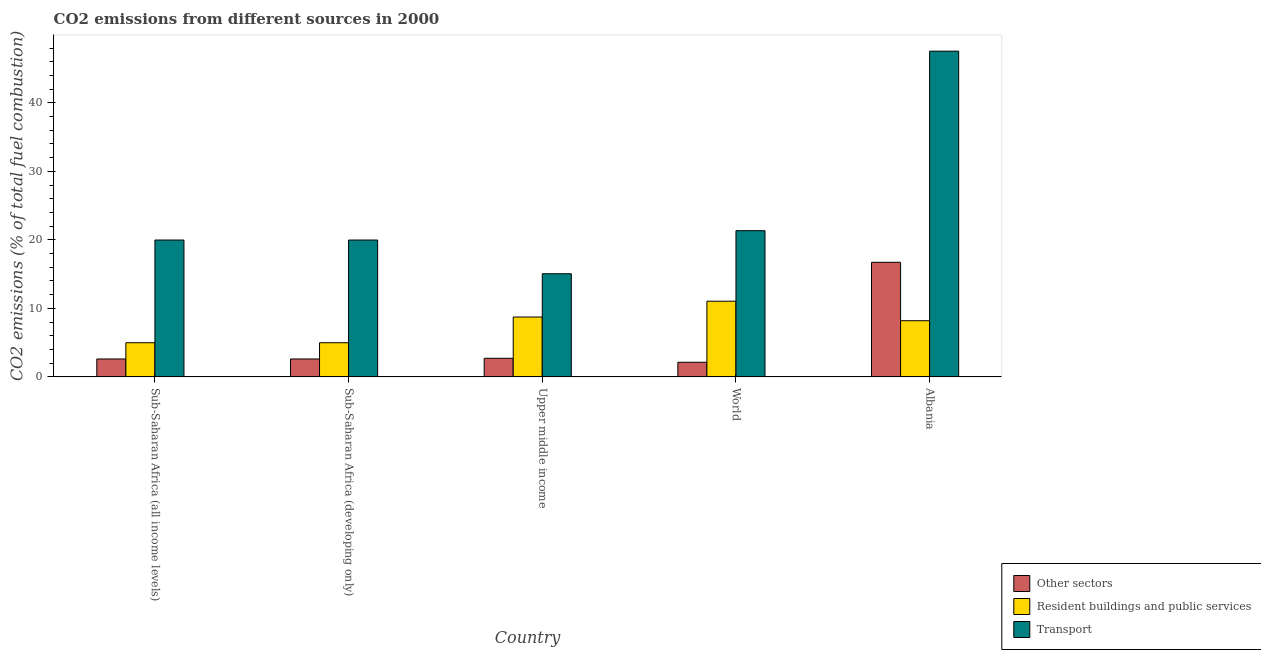How many different coloured bars are there?
Offer a very short reply. 3. How many groups of bars are there?
Make the answer very short. 5. Are the number of bars per tick equal to the number of legend labels?
Provide a succinct answer. Yes. Are the number of bars on each tick of the X-axis equal?
Provide a succinct answer. Yes. How many bars are there on the 4th tick from the right?
Provide a succinct answer. 3. What is the label of the 1st group of bars from the left?
Your response must be concise. Sub-Saharan Africa (all income levels). In how many cases, is the number of bars for a given country not equal to the number of legend labels?
Make the answer very short. 0. What is the percentage of co2 emissions from other sectors in Albania?
Provide a succinct answer. 16.72. Across all countries, what is the maximum percentage of co2 emissions from transport?
Your response must be concise. 47.54. Across all countries, what is the minimum percentage of co2 emissions from transport?
Offer a very short reply. 15.05. In which country was the percentage of co2 emissions from transport minimum?
Offer a terse response. Upper middle income. What is the total percentage of co2 emissions from other sectors in the graph?
Provide a succinct answer. 26.79. What is the difference between the percentage of co2 emissions from transport in Albania and that in Sub-Saharan Africa (developing only)?
Offer a very short reply. 27.57. What is the difference between the percentage of co2 emissions from resident buildings and public services in Sub-Saharan Africa (all income levels) and the percentage of co2 emissions from other sectors in Upper middle income?
Provide a succinct answer. 2.27. What is the average percentage of co2 emissions from transport per country?
Give a very brief answer. 24.78. What is the difference between the percentage of co2 emissions from transport and percentage of co2 emissions from other sectors in World?
Offer a very short reply. 19.2. In how many countries, is the percentage of co2 emissions from resident buildings and public services greater than 22 %?
Your answer should be compact. 0. What is the ratio of the percentage of co2 emissions from resident buildings and public services in Albania to that in Sub-Saharan Africa (all income levels)?
Ensure brevity in your answer.  1.64. What is the difference between the highest and the second highest percentage of co2 emissions from transport?
Provide a succinct answer. 26.2. What is the difference between the highest and the lowest percentage of co2 emissions from transport?
Provide a succinct answer. 32.49. In how many countries, is the percentage of co2 emissions from other sectors greater than the average percentage of co2 emissions from other sectors taken over all countries?
Your answer should be very brief. 1. Is the sum of the percentage of co2 emissions from other sectors in Sub-Saharan Africa (all income levels) and World greater than the maximum percentage of co2 emissions from transport across all countries?
Ensure brevity in your answer.  No. What does the 1st bar from the left in Upper middle income represents?
Ensure brevity in your answer.  Other sectors. What does the 1st bar from the right in Upper middle income represents?
Keep it short and to the point. Transport. How many countries are there in the graph?
Provide a succinct answer. 5. What is the difference between two consecutive major ticks on the Y-axis?
Offer a terse response. 10. Are the values on the major ticks of Y-axis written in scientific E-notation?
Keep it short and to the point. No. Does the graph contain any zero values?
Your answer should be very brief. No. Does the graph contain grids?
Your answer should be very brief. No. How many legend labels are there?
Your answer should be very brief. 3. How are the legend labels stacked?
Offer a terse response. Vertical. What is the title of the graph?
Your answer should be very brief. CO2 emissions from different sources in 2000. What is the label or title of the X-axis?
Provide a short and direct response. Country. What is the label or title of the Y-axis?
Give a very brief answer. CO2 emissions (% of total fuel combustion). What is the CO2 emissions (% of total fuel combustion) of Other sectors in Sub-Saharan Africa (all income levels)?
Make the answer very short. 2.61. What is the CO2 emissions (% of total fuel combustion) of Resident buildings and public services in Sub-Saharan Africa (all income levels)?
Provide a succinct answer. 4.98. What is the CO2 emissions (% of total fuel combustion) in Transport in Sub-Saharan Africa (all income levels)?
Your answer should be compact. 19.97. What is the CO2 emissions (% of total fuel combustion) of Other sectors in Sub-Saharan Africa (developing only)?
Your response must be concise. 2.61. What is the CO2 emissions (% of total fuel combustion) of Resident buildings and public services in Sub-Saharan Africa (developing only)?
Your answer should be compact. 4.98. What is the CO2 emissions (% of total fuel combustion) of Transport in Sub-Saharan Africa (developing only)?
Offer a terse response. 19.97. What is the CO2 emissions (% of total fuel combustion) in Other sectors in Upper middle income?
Keep it short and to the point. 2.71. What is the CO2 emissions (% of total fuel combustion) in Resident buildings and public services in Upper middle income?
Make the answer very short. 8.73. What is the CO2 emissions (% of total fuel combustion) of Transport in Upper middle income?
Your answer should be compact. 15.05. What is the CO2 emissions (% of total fuel combustion) in Other sectors in World?
Your answer should be very brief. 2.13. What is the CO2 emissions (% of total fuel combustion) in Resident buildings and public services in World?
Your answer should be compact. 11.04. What is the CO2 emissions (% of total fuel combustion) of Transport in World?
Offer a very short reply. 21.34. What is the CO2 emissions (% of total fuel combustion) in Other sectors in Albania?
Offer a terse response. 16.72. What is the CO2 emissions (% of total fuel combustion) of Resident buildings and public services in Albania?
Offer a very short reply. 8.2. What is the CO2 emissions (% of total fuel combustion) of Transport in Albania?
Your response must be concise. 47.54. Across all countries, what is the maximum CO2 emissions (% of total fuel combustion) in Other sectors?
Your answer should be very brief. 16.72. Across all countries, what is the maximum CO2 emissions (% of total fuel combustion) of Resident buildings and public services?
Your response must be concise. 11.04. Across all countries, what is the maximum CO2 emissions (% of total fuel combustion) in Transport?
Offer a terse response. 47.54. Across all countries, what is the minimum CO2 emissions (% of total fuel combustion) of Other sectors?
Your answer should be compact. 2.13. Across all countries, what is the minimum CO2 emissions (% of total fuel combustion) of Resident buildings and public services?
Give a very brief answer. 4.98. Across all countries, what is the minimum CO2 emissions (% of total fuel combustion) in Transport?
Ensure brevity in your answer.  15.05. What is the total CO2 emissions (% of total fuel combustion) in Other sectors in the graph?
Your answer should be compact. 26.79. What is the total CO2 emissions (% of total fuel combustion) in Resident buildings and public services in the graph?
Provide a succinct answer. 37.94. What is the total CO2 emissions (% of total fuel combustion) in Transport in the graph?
Provide a short and direct response. 123.88. What is the difference between the CO2 emissions (% of total fuel combustion) in Other sectors in Sub-Saharan Africa (all income levels) and that in Sub-Saharan Africa (developing only)?
Your answer should be very brief. 0. What is the difference between the CO2 emissions (% of total fuel combustion) of Resident buildings and public services in Sub-Saharan Africa (all income levels) and that in Sub-Saharan Africa (developing only)?
Offer a terse response. 0. What is the difference between the CO2 emissions (% of total fuel combustion) in Other sectors in Sub-Saharan Africa (all income levels) and that in Upper middle income?
Ensure brevity in your answer.  -0.1. What is the difference between the CO2 emissions (% of total fuel combustion) of Resident buildings and public services in Sub-Saharan Africa (all income levels) and that in Upper middle income?
Your answer should be compact. -3.75. What is the difference between the CO2 emissions (% of total fuel combustion) of Transport in Sub-Saharan Africa (all income levels) and that in Upper middle income?
Make the answer very short. 4.92. What is the difference between the CO2 emissions (% of total fuel combustion) of Other sectors in Sub-Saharan Africa (all income levels) and that in World?
Offer a very short reply. 0.48. What is the difference between the CO2 emissions (% of total fuel combustion) of Resident buildings and public services in Sub-Saharan Africa (all income levels) and that in World?
Ensure brevity in your answer.  -6.06. What is the difference between the CO2 emissions (% of total fuel combustion) in Transport in Sub-Saharan Africa (all income levels) and that in World?
Your answer should be very brief. -1.36. What is the difference between the CO2 emissions (% of total fuel combustion) in Other sectors in Sub-Saharan Africa (all income levels) and that in Albania?
Your answer should be compact. -14.11. What is the difference between the CO2 emissions (% of total fuel combustion) of Resident buildings and public services in Sub-Saharan Africa (all income levels) and that in Albania?
Your answer should be compact. -3.21. What is the difference between the CO2 emissions (% of total fuel combustion) of Transport in Sub-Saharan Africa (all income levels) and that in Albania?
Give a very brief answer. -27.57. What is the difference between the CO2 emissions (% of total fuel combustion) of Other sectors in Sub-Saharan Africa (developing only) and that in Upper middle income?
Your answer should be very brief. -0.1. What is the difference between the CO2 emissions (% of total fuel combustion) in Resident buildings and public services in Sub-Saharan Africa (developing only) and that in Upper middle income?
Offer a terse response. -3.75. What is the difference between the CO2 emissions (% of total fuel combustion) of Transport in Sub-Saharan Africa (developing only) and that in Upper middle income?
Keep it short and to the point. 4.92. What is the difference between the CO2 emissions (% of total fuel combustion) of Other sectors in Sub-Saharan Africa (developing only) and that in World?
Provide a short and direct response. 0.48. What is the difference between the CO2 emissions (% of total fuel combustion) in Resident buildings and public services in Sub-Saharan Africa (developing only) and that in World?
Provide a succinct answer. -6.06. What is the difference between the CO2 emissions (% of total fuel combustion) in Transport in Sub-Saharan Africa (developing only) and that in World?
Your answer should be very brief. -1.36. What is the difference between the CO2 emissions (% of total fuel combustion) in Other sectors in Sub-Saharan Africa (developing only) and that in Albania?
Your response must be concise. -14.11. What is the difference between the CO2 emissions (% of total fuel combustion) of Resident buildings and public services in Sub-Saharan Africa (developing only) and that in Albania?
Provide a succinct answer. -3.21. What is the difference between the CO2 emissions (% of total fuel combustion) in Transport in Sub-Saharan Africa (developing only) and that in Albania?
Your response must be concise. -27.57. What is the difference between the CO2 emissions (% of total fuel combustion) of Other sectors in Upper middle income and that in World?
Provide a short and direct response. 0.58. What is the difference between the CO2 emissions (% of total fuel combustion) of Resident buildings and public services in Upper middle income and that in World?
Offer a terse response. -2.31. What is the difference between the CO2 emissions (% of total fuel combustion) in Transport in Upper middle income and that in World?
Give a very brief answer. -6.28. What is the difference between the CO2 emissions (% of total fuel combustion) in Other sectors in Upper middle income and that in Albania?
Make the answer very short. -14.01. What is the difference between the CO2 emissions (% of total fuel combustion) of Resident buildings and public services in Upper middle income and that in Albania?
Your answer should be very brief. 0.54. What is the difference between the CO2 emissions (% of total fuel combustion) in Transport in Upper middle income and that in Albania?
Provide a succinct answer. -32.49. What is the difference between the CO2 emissions (% of total fuel combustion) in Other sectors in World and that in Albania?
Offer a terse response. -14.59. What is the difference between the CO2 emissions (% of total fuel combustion) in Resident buildings and public services in World and that in Albania?
Offer a very short reply. 2.85. What is the difference between the CO2 emissions (% of total fuel combustion) in Transport in World and that in Albania?
Offer a very short reply. -26.2. What is the difference between the CO2 emissions (% of total fuel combustion) in Other sectors in Sub-Saharan Africa (all income levels) and the CO2 emissions (% of total fuel combustion) in Resident buildings and public services in Sub-Saharan Africa (developing only)?
Your response must be concise. -2.37. What is the difference between the CO2 emissions (% of total fuel combustion) of Other sectors in Sub-Saharan Africa (all income levels) and the CO2 emissions (% of total fuel combustion) of Transport in Sub-Saharan Africa (developing only)?
Provide a succinct answer. -17.36. What is the difference between the CO2 emissions (% of total fuel combustion) in Resident buildings and public services in Sub-Saharan Africa (all income levels) and the CO2 emissions (% of total fuel combustion) in Transport in Sub-Saharan Africa (developing only)?
Offer a very short reply. -14.99. What is the difference between the CO2 emissions (% of total fuel combustion) of Other sectors in Sub-Saharan Africa (all income levels) and the CO2 emissions (% of total fuel combustion) of Resident buildings and public services in Upper middle income?
Your answer should be compact. -6.12. What is the difference between the CO2 emissions (% of total fuel combustion) of Other sectors in Sub-Saharan Africa (all income levels) and the CO2 emissions (% of total fuel combustion) of Transport in Upper middle income?
Provide a succinct answer. -12.44. What is the difference between the CO2 emissions (% of total fuel combustion) of Resident buildings and public services in Sub-Saharan Africa (all income levels) and the CO2 emissions (% of total fuel combustion) of Transport in Upper middle income?
Offer a very short reply. -10.07. What is the difference between the CO2 emissions (% of total fuel combustion) in Other sectors in Sub-Saharan Africa (all income levels) and the CO2 emissions (% of total fuel combustion) in Resident buildings and public services in World?
Your answer should be compact. -8.43. What is the difference between the CO2 emissions (% of total fuel combustion) of Other sectors in Sub-Saharan Africa (all income levels) and the CO2 emissions (% of total fuel combustion) of Transport in World?
Make the answer very short. -18.73. What is the difference between the CO2 emissions (% of total fuel combustion) of Resident buildings and public services in Sub-Saharan Africa (all income levels) and the CO2 emissions (% of total fuel combustion) of Transport in World?
Offer a terse response. -16.35. What is the difference between the CO2 emissions (% of total fuel combustion) of Other sectors in Sub-Saharan Africa (all income levels) and the CO2 emissions (% of total fuel combustion) of Resident buildings and public services in Albania?
Offer a very short reply. -5.59. What is the difference between the CO2 emissions (% of total fuel combustion) of Other sectors in Sub-Saharan Africa (all income levels) and the CO2 emissions (% of total fuel combustion) of Transport in Albania?
Provide a succinct answer. -44.93. What is the difference between the CO2 emissions (% of total fuel combustion) in Resident buildings and public services in Sub-Saharan Africa (all income levels) and the CO2 emissions (% of total fuel combustion) in Transport in Albania?
Provide a succinct answer. -42.56. What is the difference between the CO2 emissions (% of total fuel combustion) of Other sectors in Sub-Saharan Africa (developing only) and the CO2 emissions (% of total fuel combustion) of Resident buildings and public services in Upper middle income?
Offer a very short reply. -6.12. What is the difference between the CO2 emissions (% of total fuel combustion) in Other sectors in Sub-Saharan Africa (developing only) and the CO2 emissions (% of total fuel combustion) in Transport in Upper middle income?
Ensure brevity in your answer.  -12.44. What is the difference between the CO2 emissions (% of total fuel combustion) of Resident buildings and public services in Sub-Saharan Africa (developing only) and the CO2 emissions (% of total fuel combustion) of Transport in Upper middle income?
Offer a very short reply. -10.07. What is the difference between the CO2 emissions (% of total fuel combustion) in Other sectors in Sub-Saharan Africa (developing only) and the CO2 emissions (% of total fuel combustion) in Resident buildings and public services in World?
Offer a terse response. -8.43. What is the difference between the CO2 emissions (% of total fuel combustion) of Other sectors in Sub-Saharan Africa (developing only) and the CO2 emissions (% of total fuel combustion) of Transport in World?
Your answer should be compact. -18.73. What is the difference between the CO2 emissions (% of total fuel combustion) in Resident buildings and public services in Sub-Saharan Africa (developing only) and the CO2 emissions (% of total fuel combustion) in Transport in World?
Offer a very short reply. -16.35. What is the difference between the CO2 emissions (% of total fuel combustion) in Other sectors in Sub-Saharan Africa (developing only) and the CO2 emissions (% of total fuel combustion) in Resident buildings and public services in Albania?
Ensure brevity in your answer.  -5.59. What is the difference between the CO2 emissions (% of total fuel combustion) of Other sectors in Sub-Saharan Africa (developing only) and the CO2 emissions (% of total fuel combustion) of Transport in Albania?
Offer a very short reply. -44.93. What is the difference between the CO2 emissions (% of total fuel combustion) in Resident buildings and public services in Sub-Saharan Africa (developing only) and the CO2 emissions (% of total fuel combustion) in Transport in Albania?
Provide a short and direct response. -42.56. What is the difference between the CO2 emissions (% of total fuel combustion) in Other sectors in Upper middle income and the CO2 emissions (% of total fuel combustion) in Resident buildings and public services in World?
Ensure brevity in your answer.  -8.33. What is the difference between the CO2 emissions (% of total fuel combustion) of Other sectors in Upper middle income and the CO2 emissions (% of total fuel combustion) of Transport in World?
Keep it short and to the point. -18.62. What is the difference between the CO2 emissions (% of total fuel combustion) in Resident buildings and public services in Upper middle income and the CO2 emissions (% of total fuel combustion) in Transport in World?
Offer a terse response. -12.6. What is the difference between the CO2 emissions (% of total fuel combustion) of Other sectors in Upper middle income and the CO2 emissions (% of total fuel combustion) of Resident buildings and public services in Albania?
Keep it short and to the point. -5.48. What is the difference between the CO2 emissions (% of total fuel combustion) in Other sectors in Upper middle income and the CO2 emissions (% of total fuel combustion) in Transport in Albania?
Your response must be concise. -44.83. What is the difference between the CO2 emissions (% of total fuel combustion) in Resident buildings and public services in Upper middle income and the CO2 emissions (% of total fuel combustion) in Transport in Albania?
Your answer should be compact. -38.81. What is the difference between the CO2 emissions (% of total fuel combustion) of Other sectors in World and the CO2 emissions (% of total fuel combustion) of Resident buildings and public services in Albania?
Make the answer very short. -6.06. What is the difference between the CO2 emissions (% of total fuel combustion) of Other sectors in World and the CO2 emissions (% of total fuel combustion) of Transport in Albania?
Provide a short and direct response. -45.41. What is the difference between the CO2 emissions (% of total fuel combustion) of Resident buildings and public services in World and the CO2 emissions (% of total fuel combustion) of Transport in Albania?
Offer a very short reply. -36.5. What is the average CO2 emissions (% of total fuel combustion) in Other sectors per country?
Provide a succinct answer. 5.36. What is the average CO2 emissions (% of total fuel combustion) in Resident buildings and public services per country?
Provide a succinct answer. 7.59. What is the average CO2 emissions (% of total fuel combustion) of Transport per country?
Provide a succinct answer. 24.78. What is the difference between the CO2 emissions (% of total fuel combustion) of Other sectors and CO2 emissions (% of total fuel combustion) of Resident buildings and public services in Sub-Saharan Africa (all income levels)?
Make the answer very short. -2.37. What is the difference between the CO2 emissions (% of total fuel combustion) of Other sectors and CO2 emissions (% of total fuel combustion) of Transport in Sub-Saharan Africa (all income levels)?
Your response must be concise. -17.36. What is the difference between the CO2 emissions (% of total fuel combustion) in Resident buildings and public services and CO2 emissions (% of total fuel combustion) in Transport in Sub-Saharan Africa (all income levels)?
Your answer should be compact. -14.99. What is the difference between the CO2 emissions (% of total fuel combustion) in Other sectors and CO2 emissions (% of total fuel combustion) in Resident buildings and public services in Sub-Saharan Africa (developing only)?
Provide a short and direct response. -2.37. What is the difference between the CO2 emissions (% of total fuel combustion) in Other sectors and CO2 emissions (% of total fuel combustion) in Transport in Sub-Saharan Africa (developing only)?
Keep it short and to the point. -17.36. What is the difference between the CO2 emissions (% of total fuel combustion) of Resident buildings and public services and CO2 emissions (% of total fuel combustion) of Transport in Sub-Saharan Africa (developing only)?
Ensure brevity in your answer.  -14.99. What is the difference between the CO2 emissions (% of total fuel combustion) in Other sectors and CO2 emissions (% of total fuel combustion) in Resident buildings and public services in Upper middle income?
Offer a terse response. -6.02. What is the difference between the CO2 emissions (% of total fuel combustion) of Other sectors and CO2 emissions (% of total fuel combustion) of Transport in Upper middle income?
Your answer should be compact. -12.34. What is the difference between the CO2 emissions (% of total fuel combustion) in Resident buildings and public services and CO2 emissions (% of total fuel combustion) in Transport in Upper middle income?
Provide a succinct answer. -6.32. What is the difference between the CO2 emissions (% of total fuel combustion) of Other sectors and CO2 emissions (% of total fuel combustion) of Resident buildings and public services in World?
Provide a short and direct response. -8.91. What is the difference between the CO2 emissions (% of total fuel combustion) in Other sectors and CO2 emissions (% of total fuel combustion) in Transport in World?
Your response must be concise. -19.2. What is the difference between the CO2 emissions (% of total fuel combustion) in Resident buildings and public services and CO2 emissions (% of total fuel combustion) in Transport in World?
Provide a short and direct response. -10.29. What is the difference between the CO2 emissions (% of total fuel combustion) in Other sectors and CO2 emissions (% of total fuel combustion) in Resident buildings and public services in Albania?
Provide a succinct answer. 8.52. What is the difference between the CO2 emissions (% of total fuel combustion) in Other sectors and CO2 emissions (% of total fuel combustion) in Transport in Albania?
Keep it short and to the point. -30.82. What is the difference between the CO2 emissions (% of total fuel combustion) in Resident buildings and public services and CO2 emissions (% of total fuel combustion) in Transport in Albania?
Your response must be concise. -39.34. What is the ratio of the CO2 emissions (% of total fuel combustion) in Other sectors in Sub-Saharan Africa (all income levels) to that in Sub-Saharan Africa (developing only)?
Keep it short and to the point. 1. What is the ratio of the CO2 emissions (% of total fuel combustion) of Other sectors in Sub-Saharan Africa (all income levels) to that in Upper middle income?
Your response must be concise. 0.96. What is the ratio of the CO2 emissions (% of total fuel combustion) in Resident buildings and public services in Sub-Saharan Africa (all income levels) to that in Upper middle income?
Offer a very short reply. 0.57. What is the ratio of the CO2 emissions (% of total fuel combustion) of Transport in Sub-Saharan Africa (all income levels) to that in Upper middle income?
Make the answer very short. 1.33. What is the ratio of the CO2 emissions (% of total fuel combustion) of Other sectors in Sub-Saharan Africa (all income levels) to that in World?
Offer a terse response. 1.22. What is the ratio of the CO2 emissions (% of total fuel combustion) of Resident buildings and public services in Sub-Saharan Africa (all income levels) to that in World?
Ensure brevity in your answer.  0.45. What is the ratio of the CO2 emissions (% of total fuel combustion) of Transport in Sub-Saharan Africa (all income levels) to that in World?
Your answer should be very brief. 0.94. What is the ratio of the CO2 emissions (% of total fuel combustion) in Other sectors in Sub-Saharan Africa (all income levels) to that in Albania?
Give a very brief answer. 0.16. What is the ratio of the CO2 emissions (% of total fuel combustion) of Resident buildings and public services in Sub-Saharan Africa (all income levels) to that in Albania?
Ensure brevity in your answer.  0.61. What is the ratio of the CO2 emissions (% of total fuel combustion) of Transport in Sub-Saharan Africa (all income levels) to that in Albania?
Your response must be concise. 0.42. What is the ratio of the CO2 emissions (% of total fuel combustion) of Other sectors in Sub-Saharan Africa (developing only) to that in Upper middle income?
Your answer should be compact. 0.96. What is the ratio of the CO2 emissions (% of total fuel combustion) in Resident buildings and public services in Sub-Saharan Africa (developing only) to that in Upper middle income?
Your response must be concise. 0.57. What is the ratio of the CO2 emissions (% of total fuel combustion) of Transport in Sub-Saharan Africa (developing only) to that in Upper middle income?
Give a very brief answer. 1.33. What is the ratio of the CO2 emissions (% of total fuel combustion) of Other sectors in Sub-Saharan Africa (developing only) to that in World?
Offer a very short reply. 1.22. What is the ratio of the CO2 emissions (% of total fuel combustion) in Resident buildings and public services in Sub-Saharan Africa (developing only) to that in World?
Provide a short and direct response. 0.45. What is the ratio of the CO2 emissions (% of total fuel combustion) in Transport in Sub-Saharan Africa (developing only) to that in World?
Provide a short and direct response. 0.94. What is the ratio of the CO2 emissions (% of total fuel combustion) of Other sectors in Sub-Saharan Africa (developing only) to that in Albania?
Your answer should be compact. 0.16. What is the ratio of the CO2 emissions (% of total fuel combustion) of Resident buildings and public services in Sub-Saharan Africa (developing only) to that in Albania?
Keep it short and to the point. 0.61. What is the ratio of the CO2 emissions (% of total fuel combustion) in Transport in Sub-Saharan Africa (developing only) to that in Albania?
Offer a very short reply. 0.42. What is the ratio of the CO2 emissions (% of total fuel combustion) in Other sectors in Upper middle income to that in World?
Your answer should be very brief. 1.27. What is the ratio of the CO2 emissions (% of total fuel combustion) in Resident buildings and public services in Upper middle income to that in World?
Your response must be concise. 0.79. What is the ratio of the CO2 emissions (% of total fuel combustion) in Transport in Upper middle income to that in World?
Provide a succinct answer. 0.71. What is the ratio of the CO2 emissions (% of total fuel combustion) of Other sectors in Upper middle income to that in Albania?
Keep it short and to the point. 0.16. What is the ratio of the CO2 emissions (% of total fuel combustion) of Resident buildings and public services in Upper middle income to that in Albania?
Your answer should be compact. 1.07. What is the ratio of the CO2 emissions (% of total fuel combustion) of Transport in Upper middle income to that in Albania?
Give a very brief answer. 0.32. What is the ratio of the CO2 emissions (% of total fuel combustion) of Other sectors in World to that in Albania?
Provide a short and direct response. 0.13. What is the ratio of the CO2 emissions (% of total fuel combustion) of Resident buildings and public services in World to that in Albania?
Offer a very short reply. 1.35. What is the ratio of the CO2 emissions (% of total fuel combustion) of Transport in World to that in Albania?
Your answer should be compact. 0.45. What is the difference between the highest and the second highest CO2 emissions (% of total fuel combustion) in Other sectors?
Offer a very short reply. 14.01. What is the difference between the highest and the second highest CO2 emissions (% of total fuel combustion) in Resident buildings and public services?
Keep it short and to the point. 2.31. What is the difference between the highest and the second highest CO2 emissions (% of total fuel combustion) of Transport?
Make the answer very short. 26.2. What is the difference between the highest and the lowest CO2 emissions (% of total fuel combustion) in Other sectors?
Ensure brevity in your answer.  14.59. What is the difference between the highest and the lowest CO2 emissions (% of total fuel combustion) in Resident buildings and public services?
Your response must be concise. 6.06. What is the difference between the highest and the lowest CO2 emissions (% of total fuel combustion) of Transport?
Ensure brevity in your answer.  32.49. 